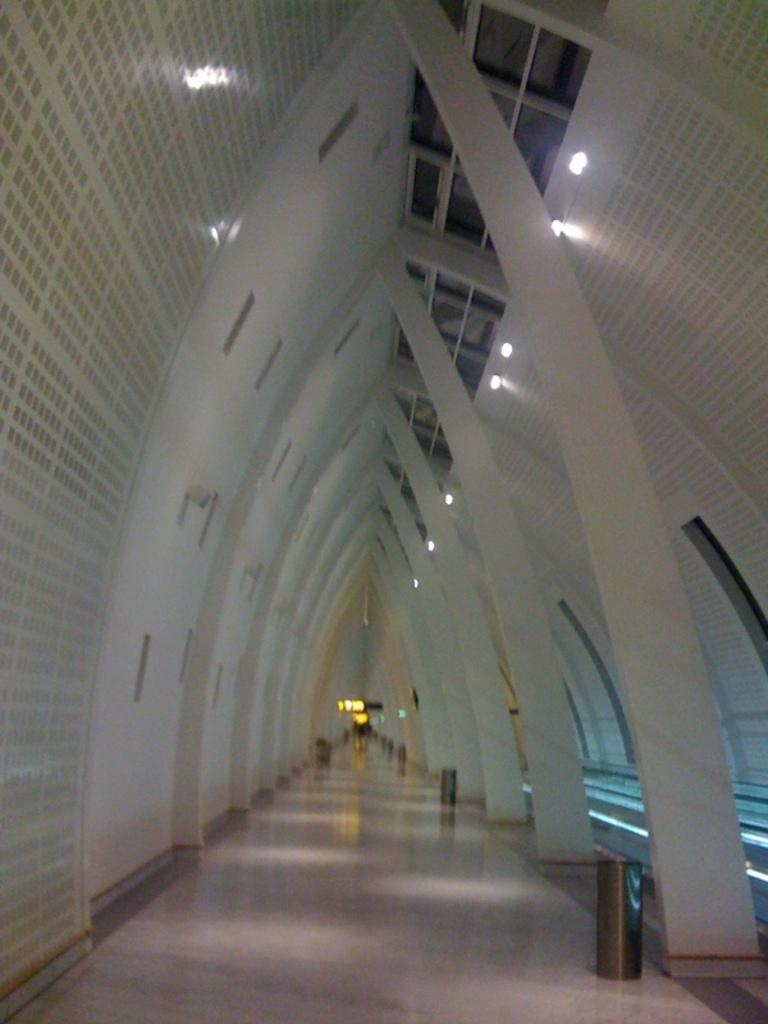Where was the image taken? The image was taken inside a building. What is the shape of the ceiling in the image? The ceiling in the image has a V-shape. What can be seen on the ceiling? There are lights on the ceiling in the image. What is present on the floor? There are dustbins and a path on the floor in the image. What is the tendency of the deer in the image? There are no deer present in the image. How many doors can be seen in the image? There is no door visible in the image. 